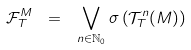Convert formula to latex. <formula><loc_0><loc_0><loc_500><loc_500>\mathcal { F } ^ { M } _ { T } \ = \ \bigvee _ { n \in \mathbb { N } _ { 0 } } \sigma \left ( \mathcal { T } ^ { n } _ { T } ( M ) \right )</formula> 